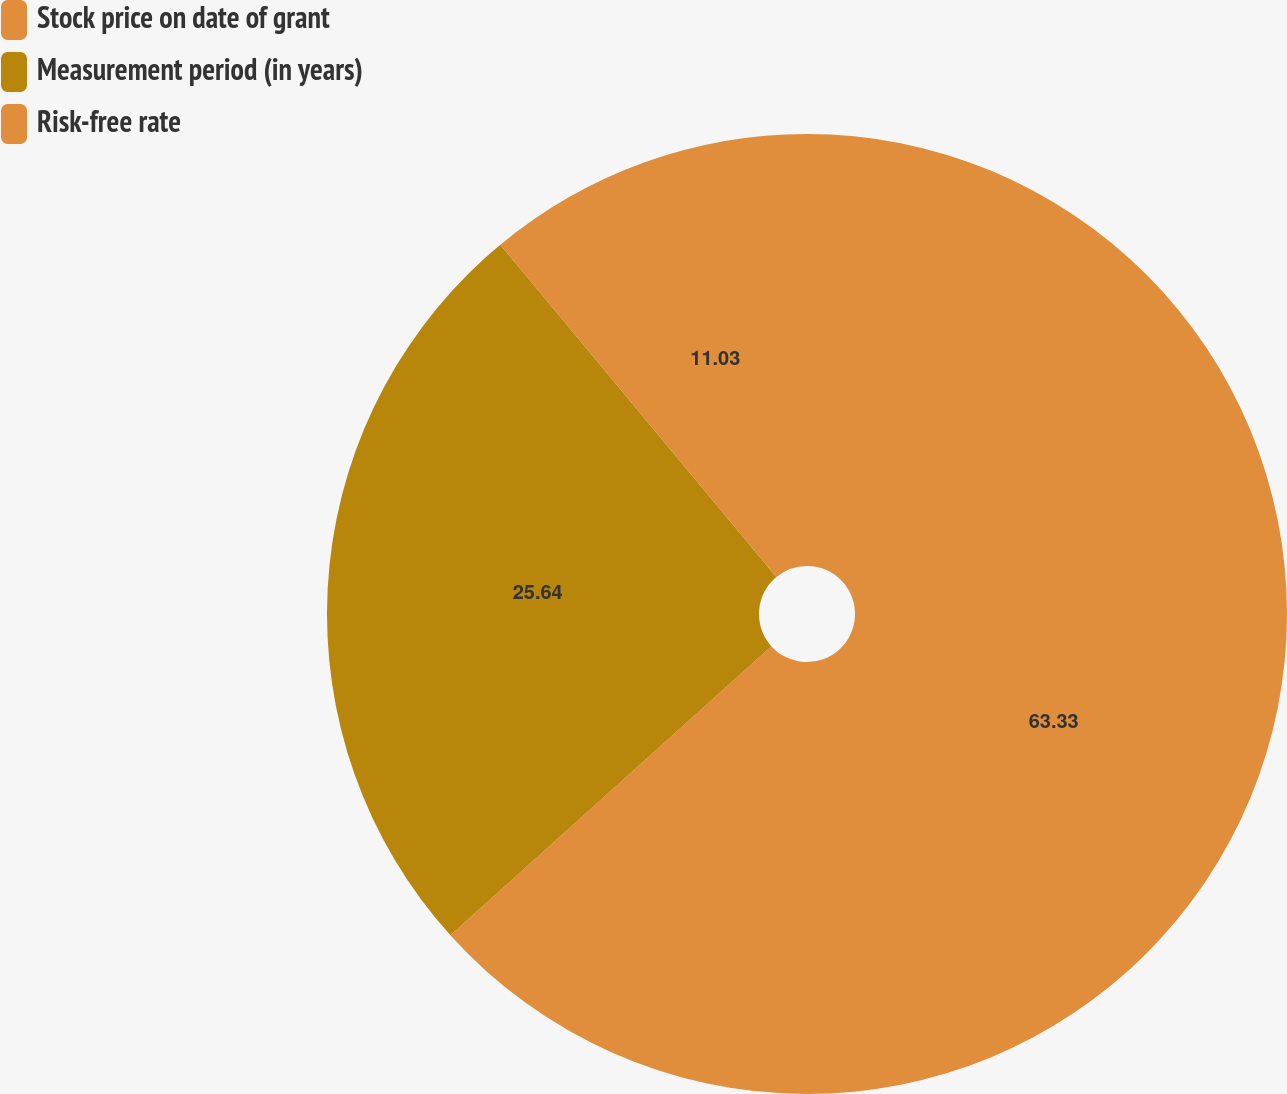Convert chart. <chart><loc_0><loc_0><loc_500><loc_500><pie_chart><fcel>Stock price on date of grant<fcel>Measurement period (in years)<fcel>Risk-free rate<nl><fcel>63.33%<fcel>25.64%<fcel>11.03%<nl></chart> 